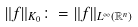<formula> <loc_0><loc_0><loc_500><loc_500>\| f \| _ { K _ { 0 } } \colon = \| f \| _ { L ^ { \infty } ( \mathbb { R } ^ { n } ) }</formula> 